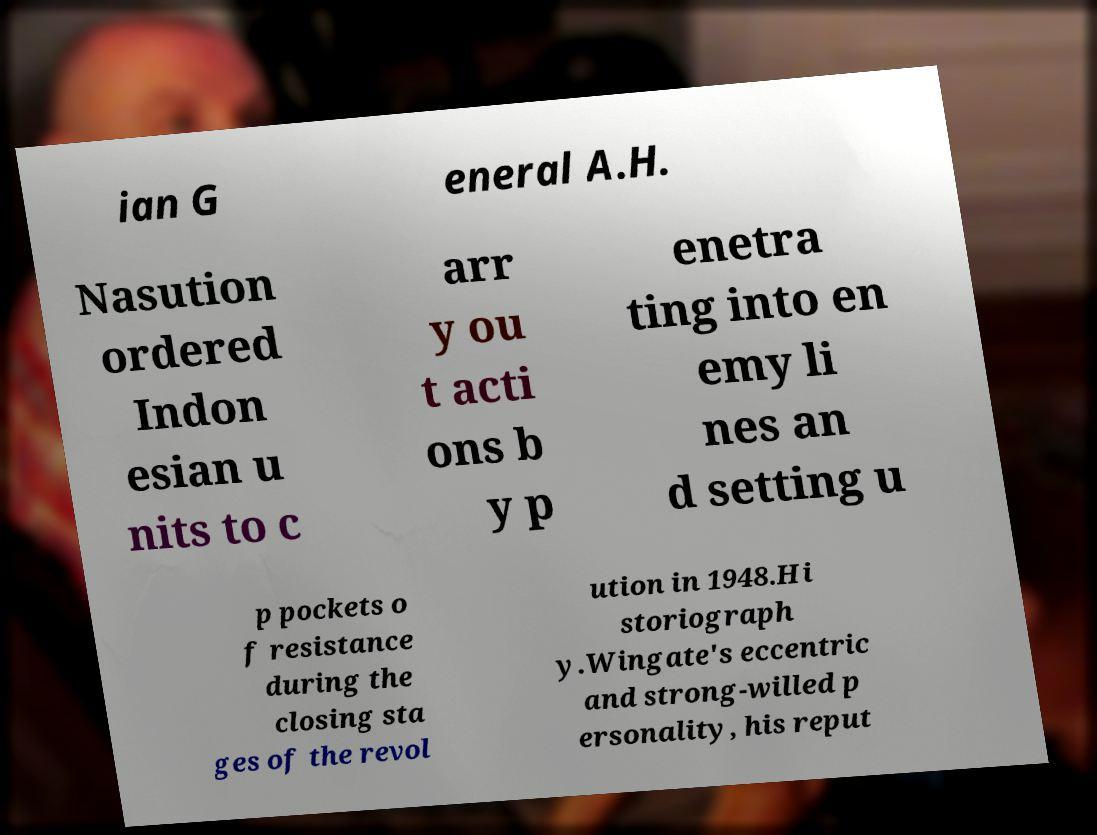I need the written content from this picture converted into text. Can you do that? ian G eneral A.H. Nasution ordered Indon esian u nits to c arr y ou t acti ons b y p enetra ting into en emy li nes an d setting u p pockets o f resistance during the closing sta ges of the revol ution in 1948.Hi storiograph y.Wingate's eccentric and strong-willed p ersonality, his reput 